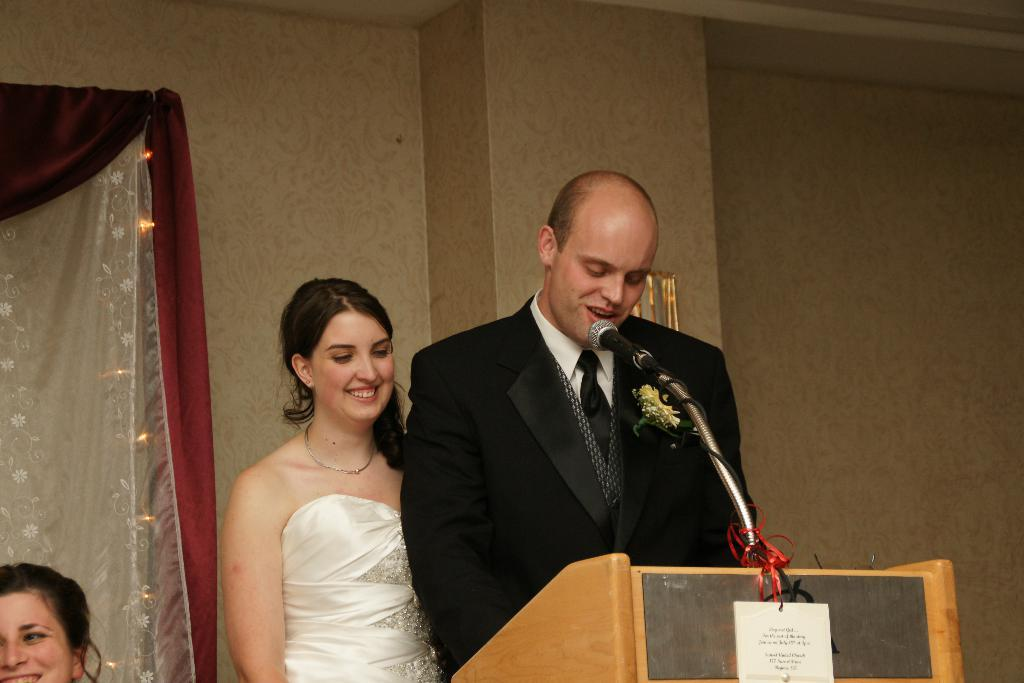How many persons are in the image? There are persons in the image, but the exact number is not specified. What object is present in the image that is typically used for amplifying sound? There is a microphone in the image. What other objects can be seen in the image besides the microphone? There are other objects in the image, but their specific details are not provided. What can be seen in the background of the image? There is a wall, curtains, and lights in the background of the image. What type of hill can be seen in the background of the image? There is no hill present in the image; only a wall, curtains, and lights are visible in the background. What kind of silk material is draped over the microphone in the image? There is no silk material present in the image; the microphone is not covered by any fabric. 